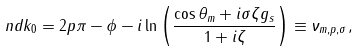<formula> <loc_0><loc_0><loc_500><loc_500>n d k _ { 0 } = 2 p \pi - \phi - i \ln \left ( \frac { \cos \theta _ { m } + i \sigma \zeta g _ { s } } { 1 + i \zeta } \right ) \equiv \nu _ { m , p , \sigma } ,</formula> 